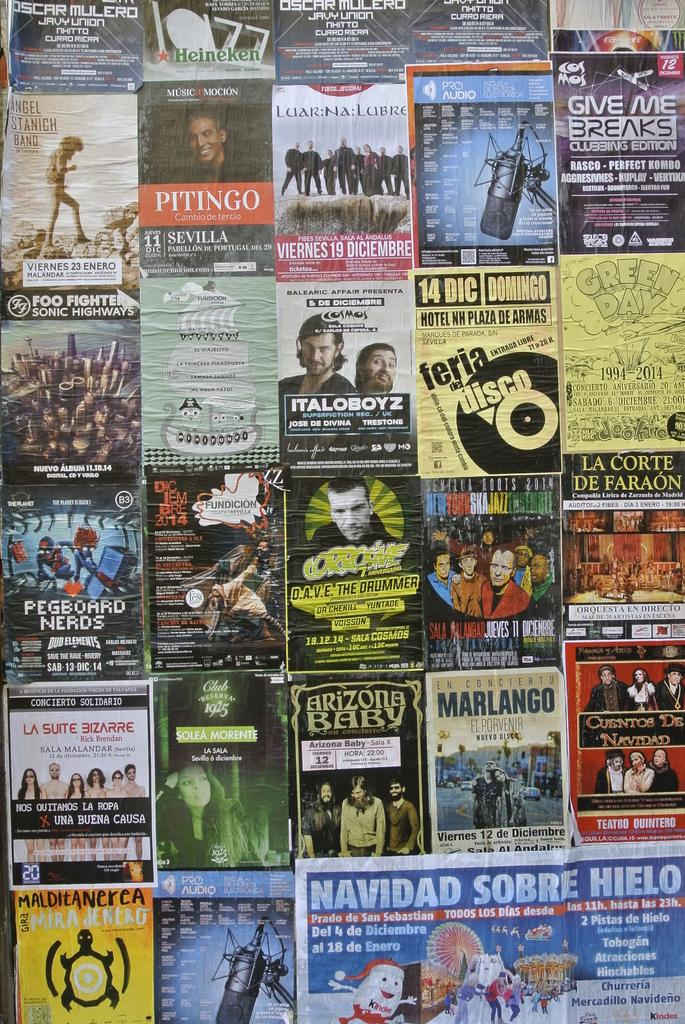<image>
Create a compact narrative representing the image presented. A wall full of posters advertising Marlango, Pegboard Nerds, etc. 